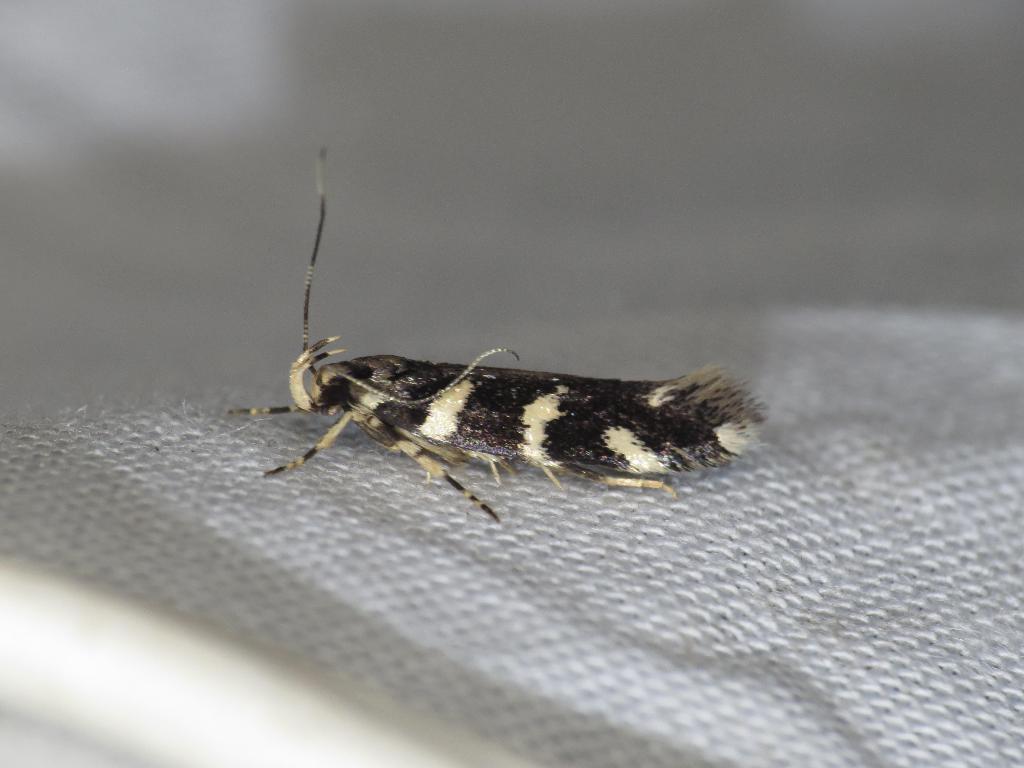Describe this image in one or two sentences. In this image, I see an insect on a cloth. 